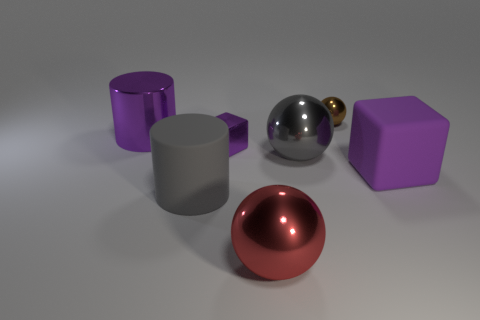Add 2 cyan rubber cubes. How many objects exist? 9 Subtract all spheres. How many objects are left? 4 Subtract 1 purple cubes. How many objects are left? 6 Subtract all cylinders. Subtract all metallic balls. How many objects are left? 2 Add 4 purple metallic cubes. How many purple metallic cubes are left? 5 Add 1 cyan spheres. How many cyan spheres exist? 1 